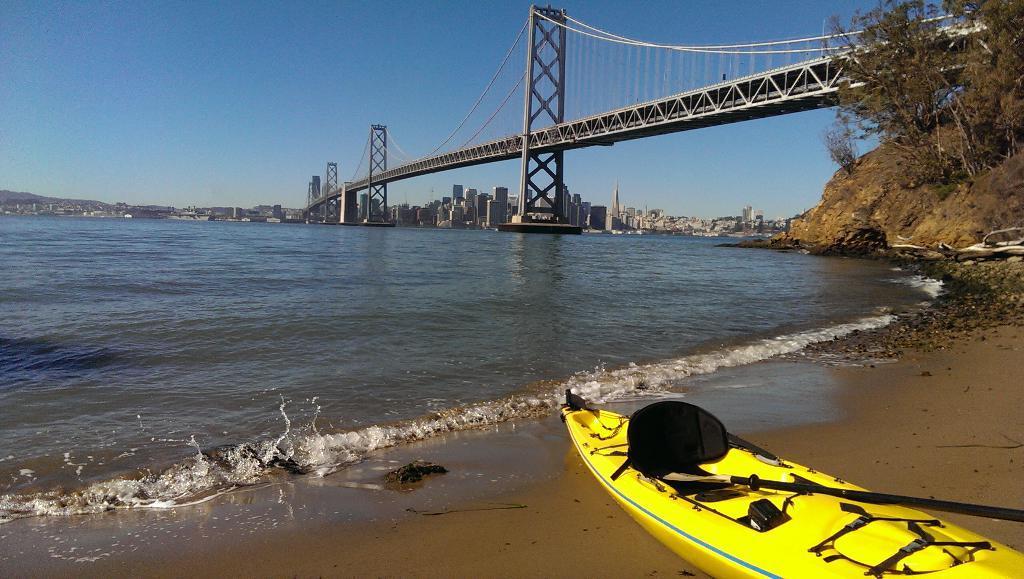Please provide a concise description of this image. In this image I can see a boat. I can see the water. On the right side, I can see the trees. I can see the bridge. In the background, I can see the buildings and the sky. 